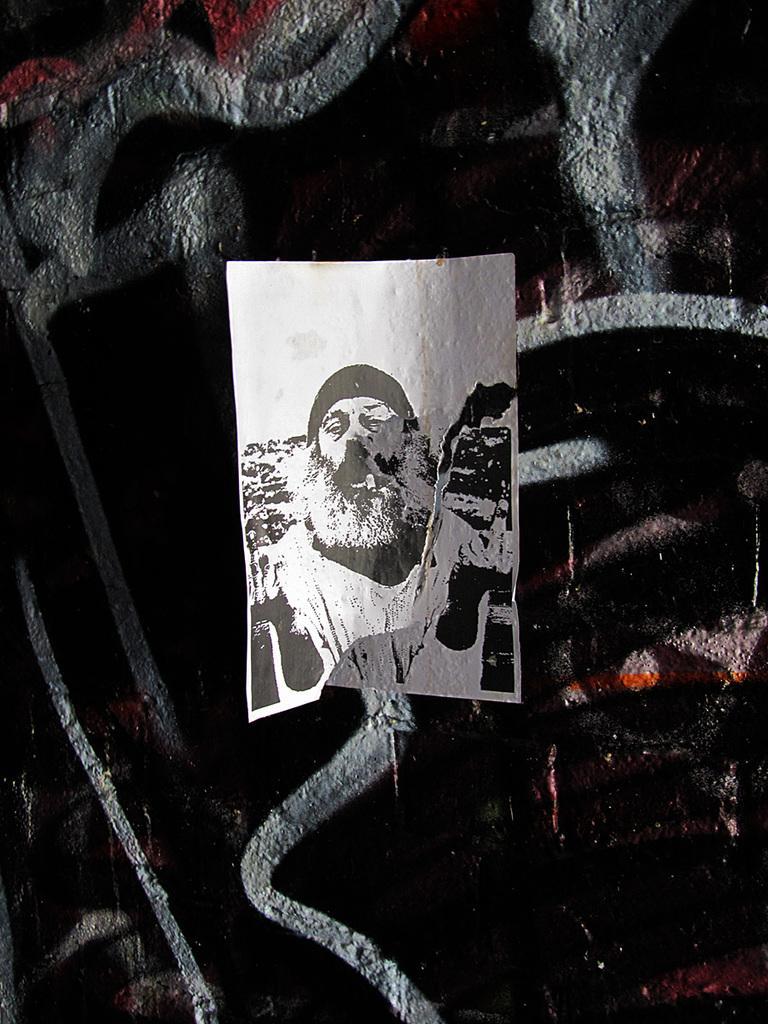Please provide a concise description of this image. This is the picture of a white and black picture which is on the cloth. 